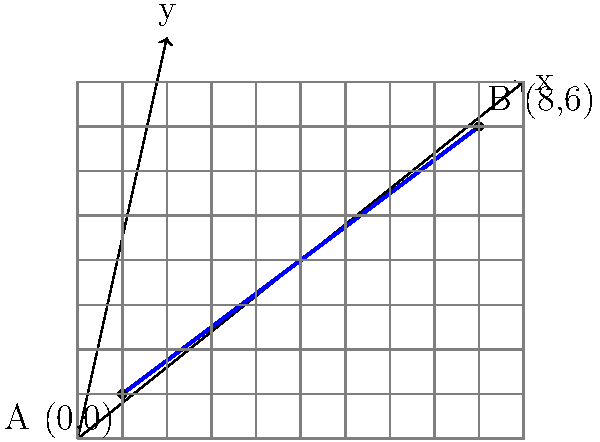As an architect interested in the Great Bend of the Nile River, you want to determine its slope for a historical site analysis. Given that the bend can be approximated by a straight line from point A (0,0) to point B (8,6) as shown in the diagram, calculate the slope of this line segment representing the Great Bend. Express your answer as a fraction in its simplest form. To find the slope of the line segment representing the Great Bend of the Nile River, we'll use the slope formula:

$$ m = \frac{y_2 - y_1}{x_2 - x_1} $$

Where $(x_1, y_1)$ is the coordinates of point A, and $(x_2, y_2)$ is the coordinates of point B.

Step 1: Identify the coordinates
- Point A: $(x_1, y_1) = (0, 0)$
- Point B: $(x_2, y_2) = (8, 6)$

Step 2: Apply the slope formula
$$ m = \frac{y_2 - y_1}{x_2 - x_1} = \frac{6 - 0}{8 - 0} = \frac{6}{8} $$

Step 3: Simplify the fraction
$$ \frac{6}{8} = \frac{3}{4} $$

Therefore, the slope of the line segment representing the Great Bend of the Nile River is $\frac{3}{4}$.
Answer: $\frac{3}{4}$ 